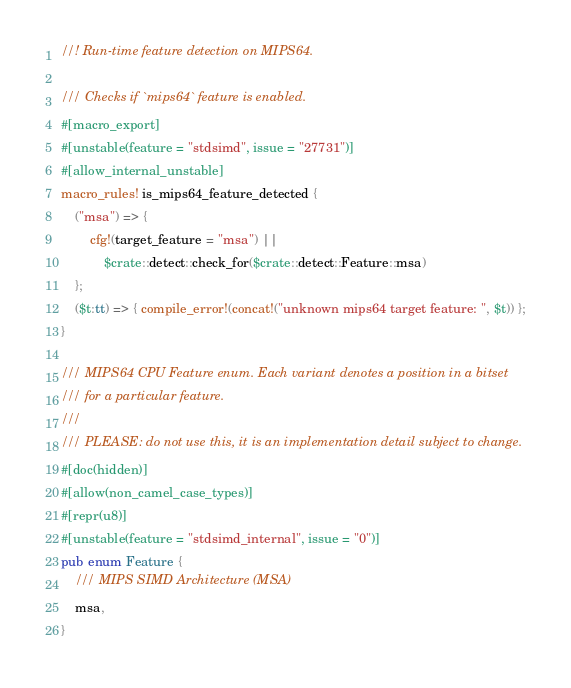Convert code to text. <code><loc_0><loc_0><loc_500><loc_500><_Rust_>//! Run-time feature detection on MIPS64.

/// Checks if `mips64` feature is enabled.
#[macro_export]
#[unstable(feature = "stdsimd", issue = "27731")]
#[allow_internal_unstable]
macro_rules! is_mips64_feature_detected {
    ("msa") => {
        cfg!(target_feature = "msa") ||
            $crate::detect::check_for($crate::detect::Feature::msa)
    };
    ($t:tt) => { compile_error!(concat!("unknown mips64 target feature: ", $t)) };
}

/// MIPS64 CPU Feature enum. Each variant denotes a position in a bitset
/// for a particular feature.
///
/// PLEASE: do not use this, it is an implementation detail subject to change.
#[doc(hidden)]
#[allow(non_camel_case_types)]
#[repr(u8)]
#[unstable(feature = "stdsimd_internal", issue = "0")]
pub enum Feature {
    /// MIPS SIMD Architecture (MSA)
    msa,
}
</code> 